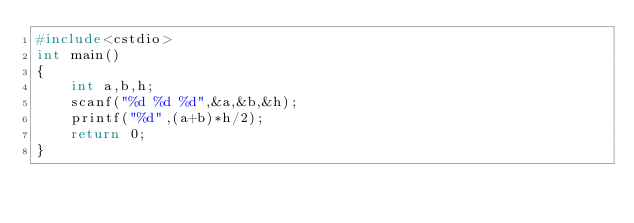<code> <loc_0><loc_0><loc_500><loc_500><_C++_>#include<cstdio>
int main()
{
	int a,b,h;
	scanf("%d %d %d",&a,&b,&h);
	printf("%d",(a+b)*h/2);
	return 0;
}</code> 